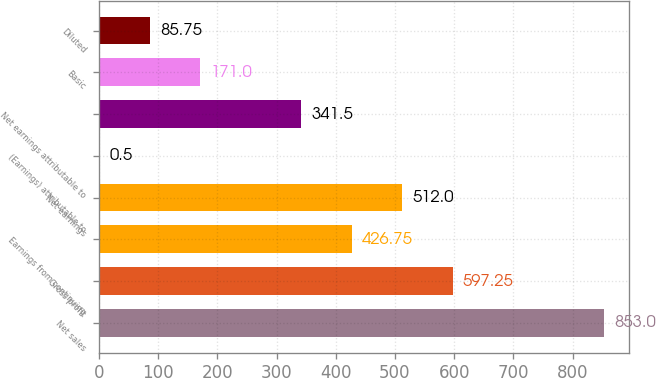<chart> <loc_0><loc_0><loc_500><loc_500><bar_chart><fcel>Net sales<fcel>Gross profit<fcel>Earnings from continuing<fcel>Net earnings<fcel>(Earnings) attributable to<fcel>Net earnings attributable to<fcel>Basic<fcel>Diluted<nl><fcel>853<fcel>597.25<fcel>426.75<fcel>512<fcel>0.5<fcel>341.5<fcel>171<fcel>85.75<nl></chart> 